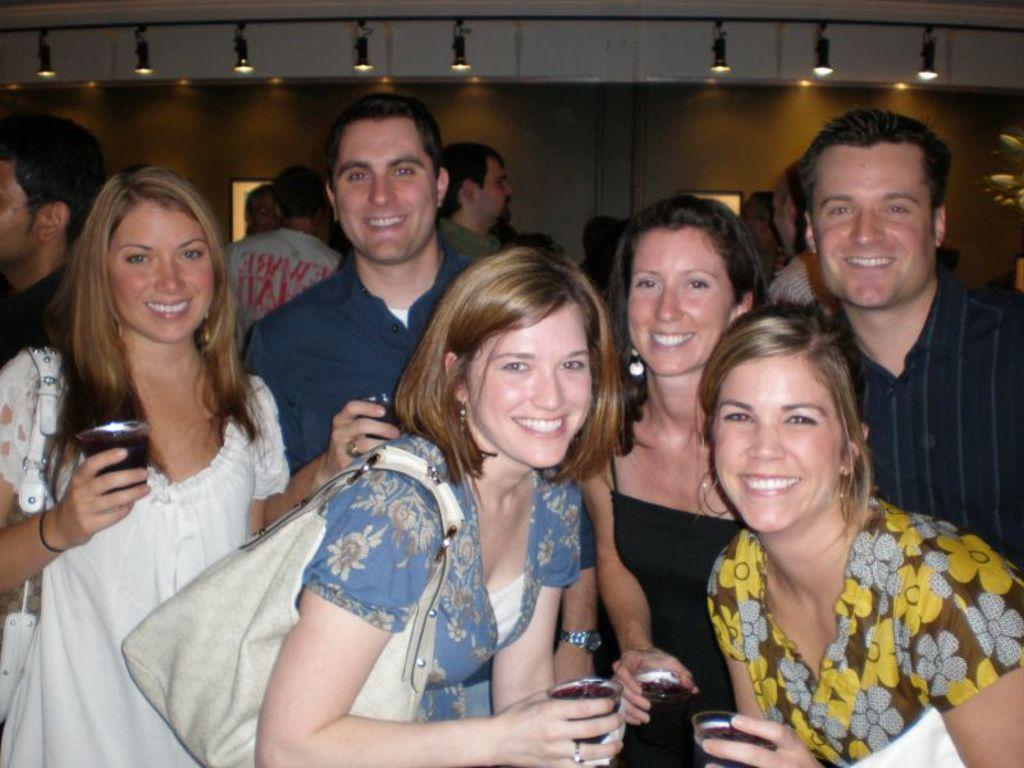What are the people in the image doing? The people in the image are posing for a camera. What expression do the people have in the image? The people are smiling in the image. What are the people holding in their hands? The people are holding glasses in their hands. What can be seen in the background of the image? There is a wall and lights in the background of the image, as well as additional people. What letter is the person holding in their hand in the image? There is no letter present in the image; the people are holding glasses in their hands. 